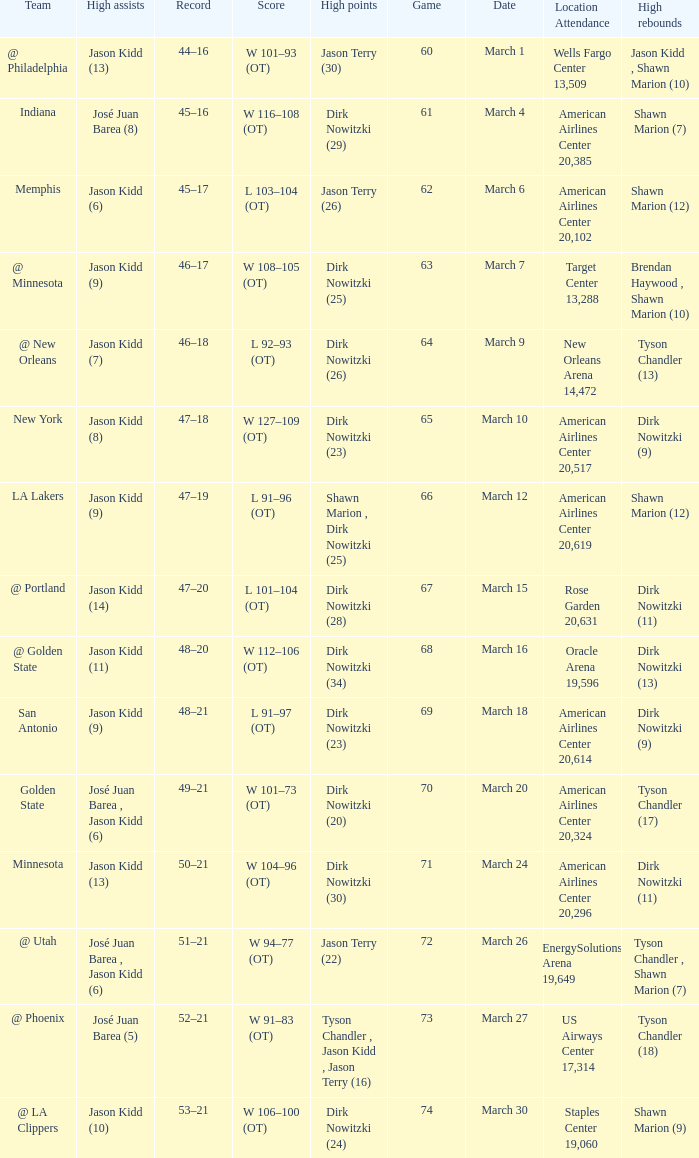Name the score for  josé juan barea (8) W 116–108 (OT). 